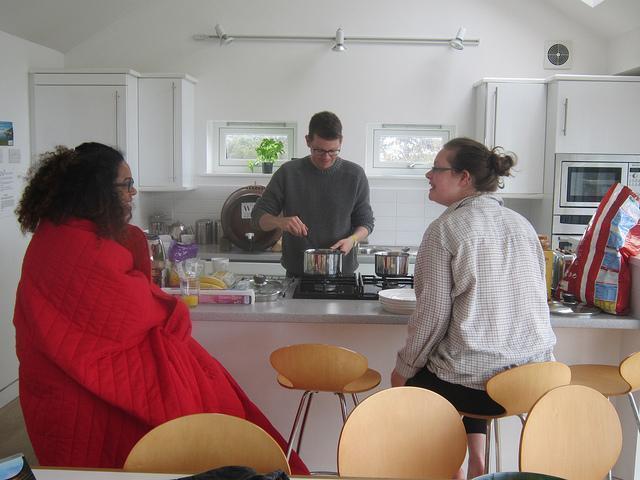How many chairs are there?
Give a very brief answer. 6. How many ovens are there?
Give a very brief answer. 2. How many chairs are visible?
Give a very brief answer. 5. How many people are visible?
Give a very brief answer. 3. How many clocks are on this tower?
Give a very brief answer. 0. 